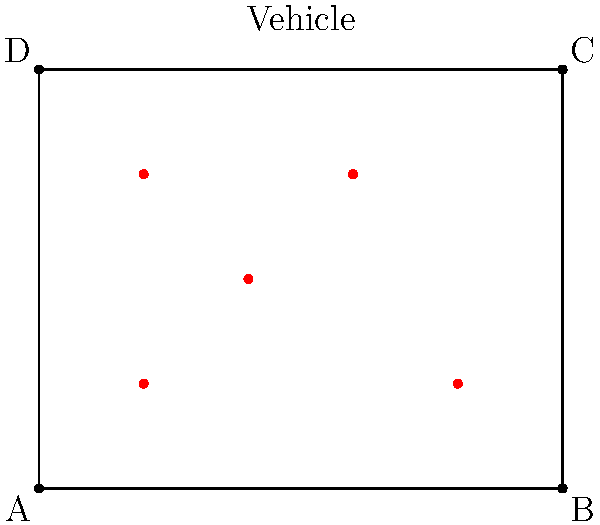In a military exercise, your son's National Guard unit needs to position 5 vehicles within a rectangular area measuring 5 units wide and 4 units tall. The vehicles are represented by red dots in the diagram. What is the minimum number of straight lines needed to connect all the vehicles, ensuring each vehicle is connected to at least one other vehicle? To solve this problem, we need to follow these steps:

1. Analyze the positions of the vehicles (red dots) in the given rectangular area.

2. Consider the concept of a minimum spanning tree, which connects all points with the least number of edges.

3. Start with any vehicle and connect it to the nearest unconnected vehicle:
   - Connect (1,1) to (2,2)
   - Connect (2,2) to (3,3)
   - Connect (3,3) to (4,1)
   - Connect (1,3) to either (1,1) or (2,2), whichever is closer

4. Count the number of connections made:
   - (1,1) to (2,2): 1 line
   - (2,2) to (3,3): 1 line
   - (3,3) to (4,1): 1 line
   - (1,3) to (2,2): 1 line

5. The total number of lines needed is 4, which is the minimum number required to connect all 5 vehicles while ensuring each vehicle is connected to at least one other vehicle.

This solution creates a spanning tree that connects all vehicles with the minimum number of edges, which in this case is 4 lines.
Answer: 4 lines 